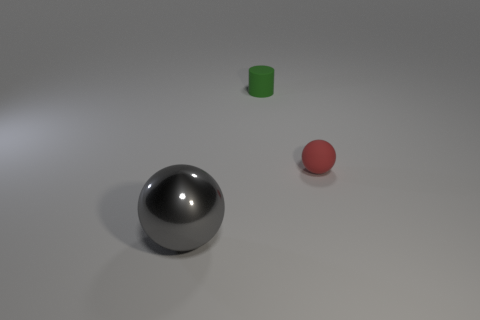Add 2 tiny yellow matte cylinders. How many objects exist? 5 Subtract all balls. How many objects are left? 1 Subtract 0 purple blocks. How many objects are left? 3 Subtract all tiny matte balls. Subtract all red rubber balls. How many objects are left? 1 Add 1 matte balls. How many matte balls are left? 2 Add 1 green rubber cylinders. How many green rubber cylinders exist? 2 